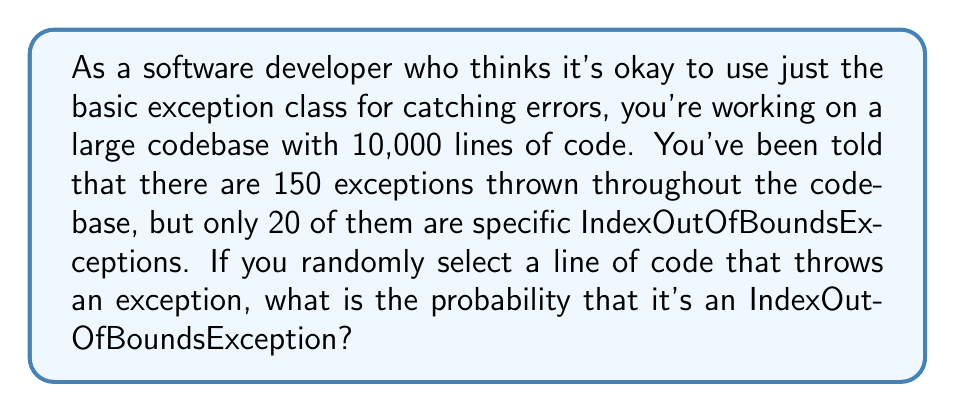Can you answer this question? To solve this problem, we need to use the concept of conditional probability. We're looking for the probability of encountering an IndexOutOfBoundsException given that we've encountered an exception.

Let's define our events:
- A: The selected line throws an exception
- B: The selected line throws an IndexOutOfBoundsException

We're given the following information:
- Total lines of code: 10,000
- Total exceptions: 150
- Total IndexOutOfBoundsExceptions: 20

Step 1: Calculate P(A), the probability of selecting a line that throws any exception.
$$P(A) = \frac{\text{Total exceptions}}{\text{Total lines of code}} = \frac{150}{10000} = 0.015$$

Step 2: Calculate P(B), the probability of selecting a line that throws an IndexOutOfBoundsException.
$$P(B) = \frac{\text{Total IndexOutOfBoundsExceptions}}{\text{Total lines of code}} = \frac{20}{10000} = 0.002$$

Step 3: Calculate P(B|A), the probability of encountering an IndexOutOfBoundsException given that we've encountered an exception.
$$P(B|A) = \frac{P(B)}{P(A)} = \frac{0.002}{0.015} = \frac{2}{15} \approx 0.1333$$

Therefore, the probability of encountering an IndexOutOfBoundsException, given that you've encountered an exception, is approximately 0.1333 or 13.33%.
Answer: $\frac{2}{15}$ or approximately $0.1333$ or $13.33\%$ 